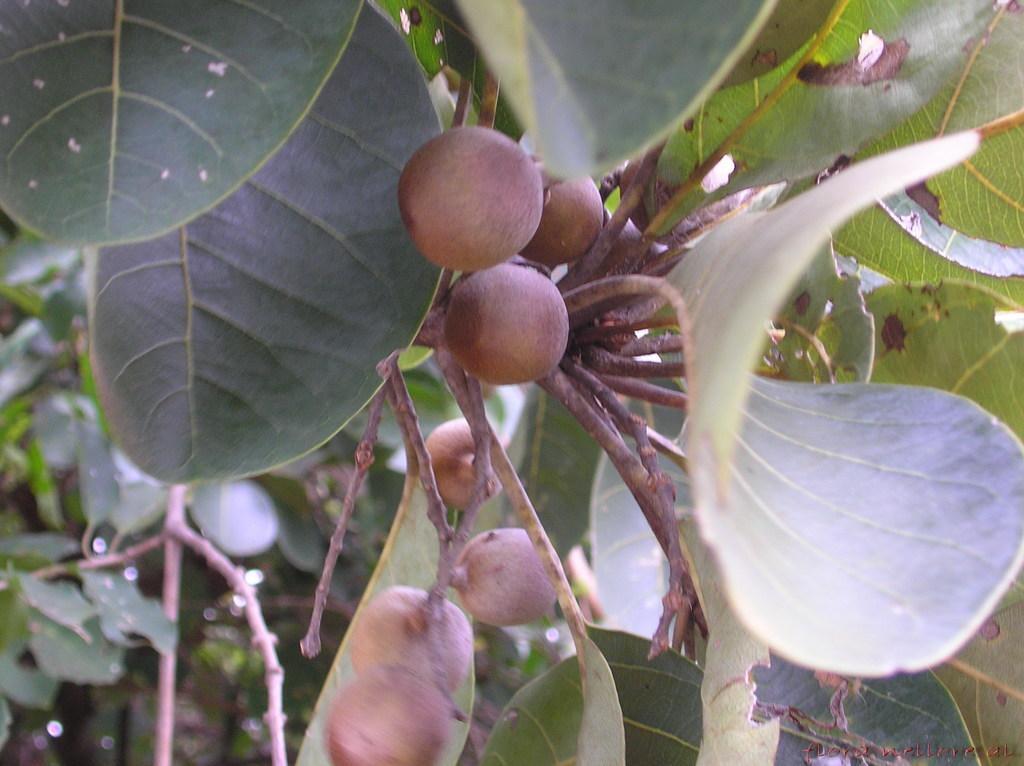Please provide a concise description of this image. In the picture we can see a plant with leaves and fruits. 